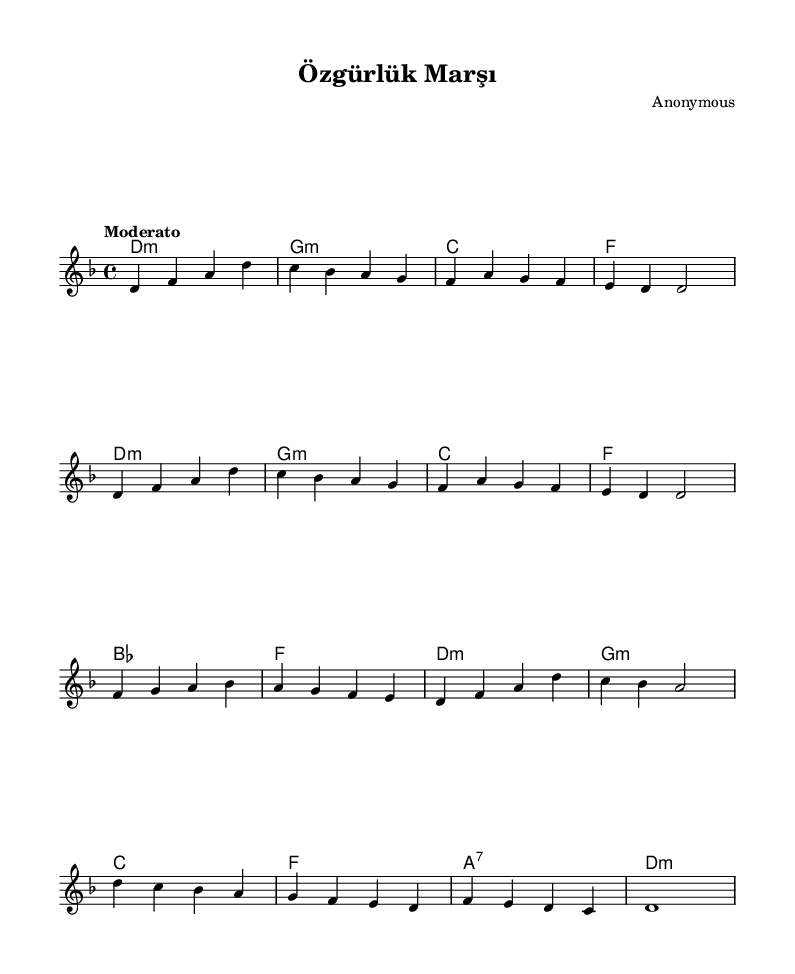What is the key signature of this music? The key signature is D minor, indicated by the presence of one flat (B flat) in the notation. This can be seen in the key signature at the beginning of the sheet music.
Answer: D minor What is the time signature of this music? The time signature is 4/4, which is represented at the beginning of the sheet music. This means there are four beats per measure, and the quarter note gets one beat.
Answer: 4/4 What tempo marking is indicated? The tempo marking is "Moderato," which suggests a moderate speed for the piece. This is generally understood as a moderately fast tempo and is found written at the start of the score.
Answer: Moderato What is the first note of the melody? The first note of the melody is D, indicated by the first note in the relative notation under the melody section.
Answer: D How many measures are in the provided melody section? The provided melody section consists of 8 measures, which can be counted by looking at the separation of notes and bar lines throughout the notation.
Answer: 8 What chord is indicated in the first measure? The chord indicated in the first measure is D minor, which can be inferred from the chord symbol placed above the staff in the sheet music.
Answer: D minor Which instrument is primarily indicated for this score? The score is primarily indicated for a staff which is typically used for instruments like the piano or any melodic instrument, as there's no explicit instrument name mentioned.
Answer: Piano 